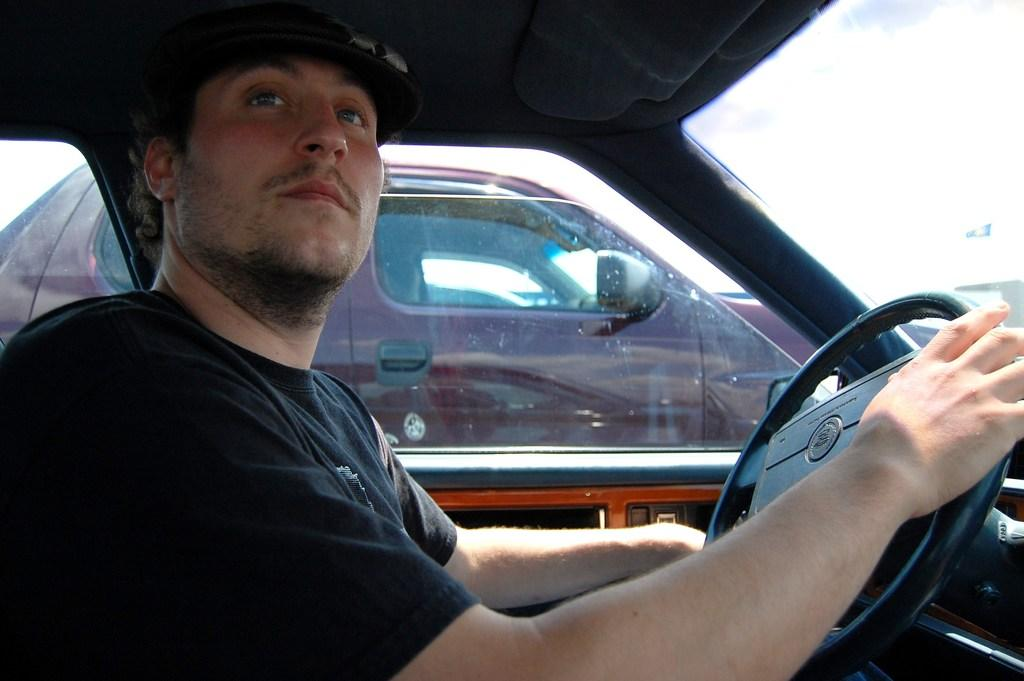What is the man in the image doing? The man is sitting in a car and holding the steering wheel. Can you describe the car beside the man's car? The other car is red in color. What is the position of the man's car in relation to the other car? The man's car is beside the other red car. What type of net is being used to catch fish in the image? There is no net or fishing activity present in the image. 